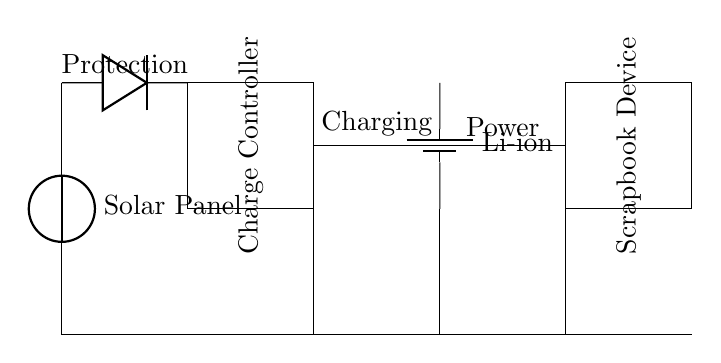What component generates power in this circuit? The solar panel is identified at the top of the circuit diagram, labeled as the source of power. It converts sunlight into electrical energy, which is essential for charging.
Answer: Solar Panel What type of battery is used in this circuit? The battery is marked in the diagram as a lithium-ion type, which is noted for its efficiency and common use in portable applications.
Answer: Li-ion How does the current flow through the circuit? The diagram shows connections from the solar panel to the diode, then to the charge controller, and subsequently to the battery and the scrap booking device. Current flows in this specific order during charging.
Answer: Solar Panel → Diode → Charge Controller → Battery → Scrapbook Device What is the purpose of the diode in this circuit? The diode allows current to flow in only one direction, protecting the circuit from backflow, which could damage components like the battery and the charge controller during discharging.
Answer: Protection How is the charge controller positioned in this circuit? The charge controller is represented as a rectangle located between the solar panel and the battery, indicating its role in managing the charging process. It regulates the voltage and current flowing to the battery.
Answer: Middle What labels indicate the specific functions of components in the circuit? The diagram includes labels such as "Protection" above the diode and "Charging" above the connections to the charge controller, indicating their respective purposes in the circuit operation.
Answer: Protection and Charging 